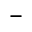<formula> <loc_0><loc_0><loc_500><loc_500>-</formula> 